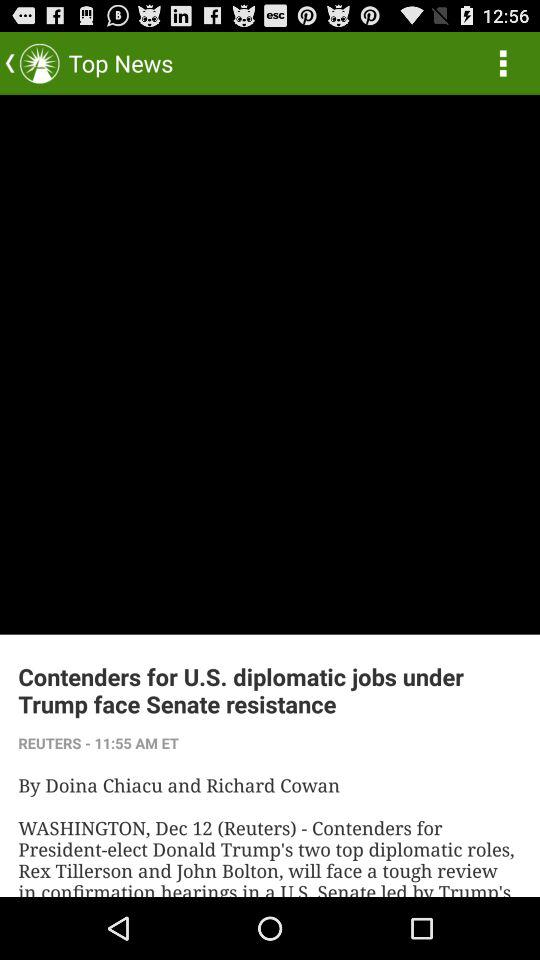What is the publication date of the article? The publication date is December 12. 